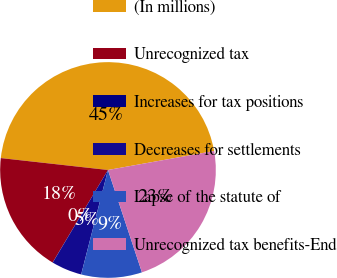<chart> <loc_0><loc_0><loc_500><loc_500><pie_chart><fcel>(In millions)<fcel>Unrecognized tax<fcel>Increases for tax positions<fcel>Decreases for settlements<fcel>Lapse of the statute of<fcel>Unrecognized tax benefits-End<nl><fcel>45.42%<fcel>18.18%<fcel>0.02%<fcel>4.56%<fcel>9.1%<fcel>22.72%<nl></chart> 